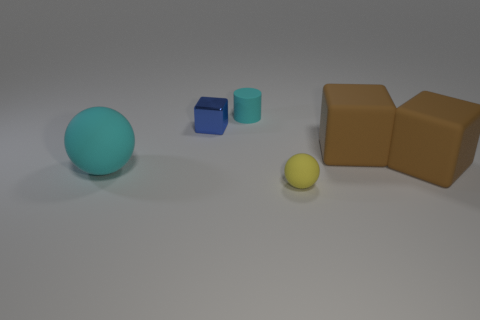Does the cylinder have the same color as the matte ball that is on the left side of the tiny metallic thing?
Make the answer very short. Yes. How many things are either big matte things to the left of the yellow ball or big things on the right side of the blue metal cube?
Provide a short and direct response. 3. How many other things are the same color as the small rubber cylinder?
Your answer should be compact. 1. Do the big cyan matte thing and the matte object in front of the cyan ball have the same shape?
Ensure brevity in your answer.  Yes. Are there fewer metallic things that are behind the blue block than blue blocks to the left of the yellow ball?
Offer a very short reply. Yes. Is there anything else that is the same material as the blue cube?
Provide a short and direct response. No. Does the small rubber cylinder have the same color as the big matte sphere?
Your answer should be compact. Yes. There is a big cyan object that is made of the same material as the tiny cylinder; what shape is it?
Ensure brevity in your answer.  Sphere. What number of cyan objects have the same shape as the yellow thing?
Offer a terse response. 1. There is a rubber thing that is in front of the large ball that is in front of the tiny cyan matte cylinder; what shape is it?
Ensure brevity in your answer.  Sphere. 